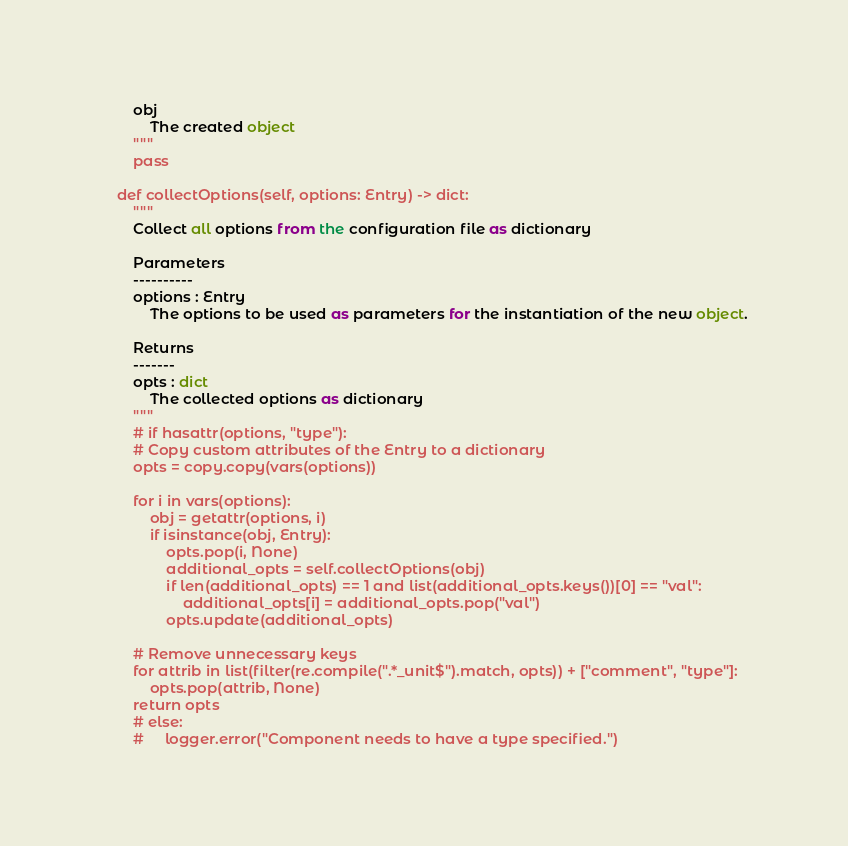Convert code to text. <code><loc_0><loc_0><loc_500><loc_500><_Python_>        obj
            The created object
        """
        pass

    def collectOptions(self, options: Entry) -> dict:
        """
        Collect all options from the configuration file as dictionary

        Parameters
        ----------
        options : Entry
            The options to be used as parameters for the instantiation of the new object.

        Returns
        -------
        opts : dict
            The collected options as dictionary
        """
        # if hasattr(options, "type"):
        # Copy custom attributes of the Entry to a dictionary
        opts = copy.copy(vars(options))

        for i in vars(options):
            obj = getattr(options, i)
            if isinstance(obj, Entry):
                opts.pop(i, None)
                additional_opts = self.collectOptions(obj)
                if len(additional_opts) == 1 and list(additional_opts.keys())[0] == "val":
                    additional_opts[i] = additional_opts.pop("val")
                opts.update(additional_opts)

        # Remove unnecessary keys
        for attrib in list(filter(re.compile(".*_unit$").match, opts)) + ["comment", "type"]:
            opts.pop(attrib, None)
        return opts
        # else:
        #     logger.error("Component needs to have a type specified.")
</code> 